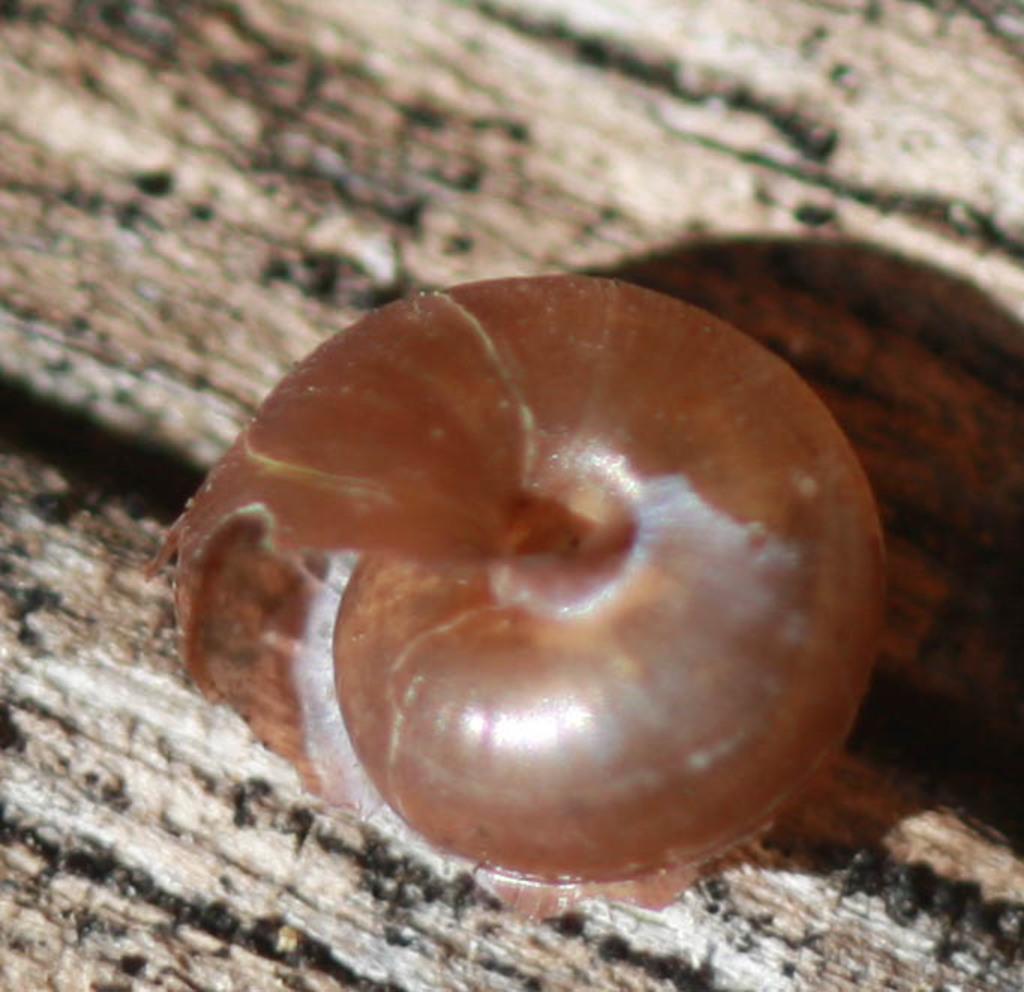In one or two sentences, can you explain what this image depicts? In this image we can see a snail shell placed on the surface. 